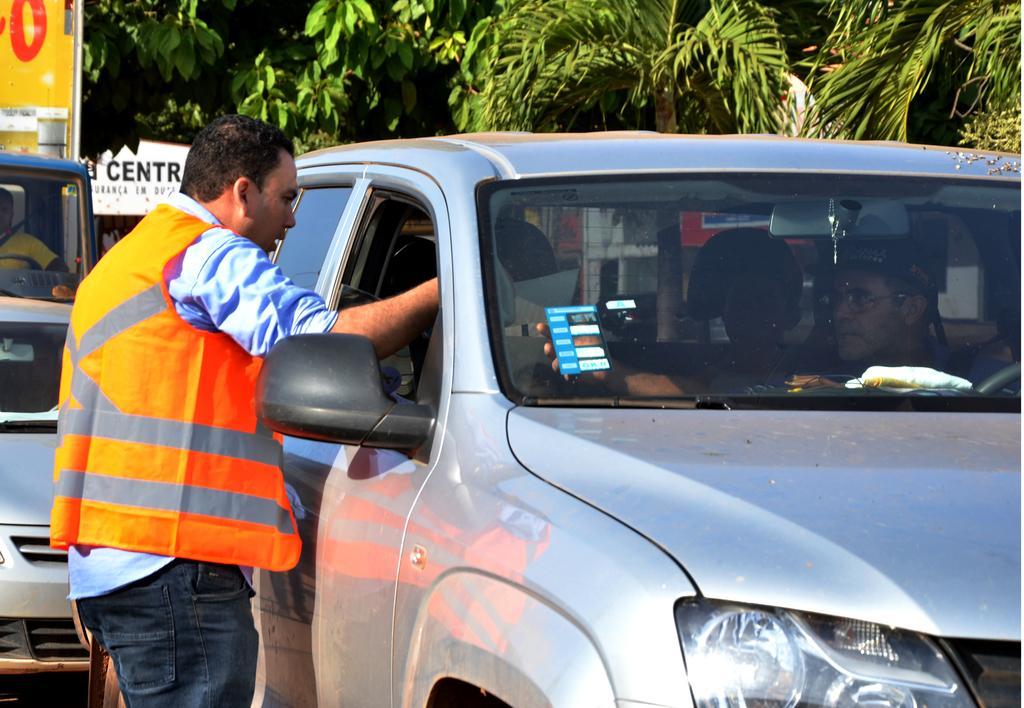Describe this image in one or two sentences. A person is sitting inside the car and the person is standing outside the car and the person is showing something to the person outside the car. Behind the car there are two vehicles and there are number of trees. 